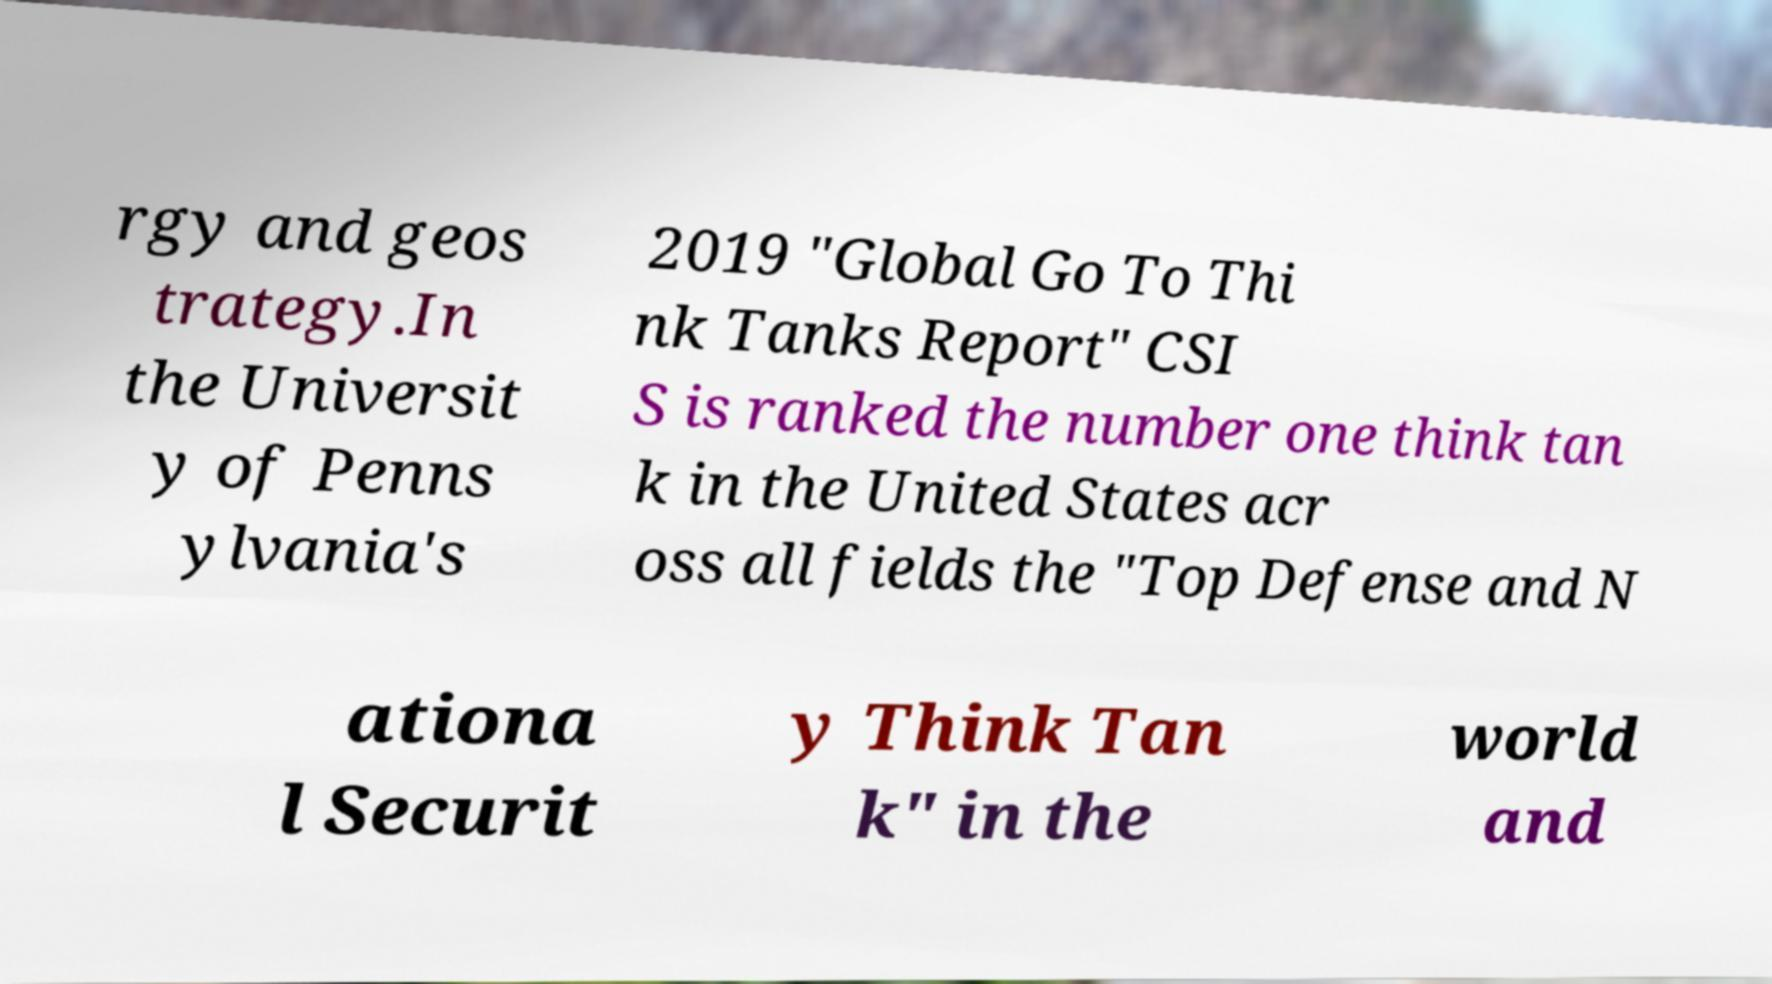What messages or text are displayed in this image? I need them in a readable, typed format. rgy and geos trategy.In the Universit y of Penns ylvania's 2019 "Global Go To Thi nk Tanks Report" CSI S is ranked the number one think tan k in the United States acr oss all fields the "Top Defense and N ationa l Securit y Think Tan k" in the world and 